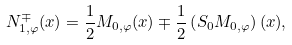<formula> <loc_0><loc_0><loc_500><loc_500>N _ { 1 , \varphi } ^ { \mp } ( x ) = \frac { 1 } { 2 } { M } _ { 0 , \varphi } ( x ) \mp \frac { 1 } { 2 } \left ( { S } _ { 0 } { M } _ { 0 , \varphi } \right ) ( x ) ,</formula> 